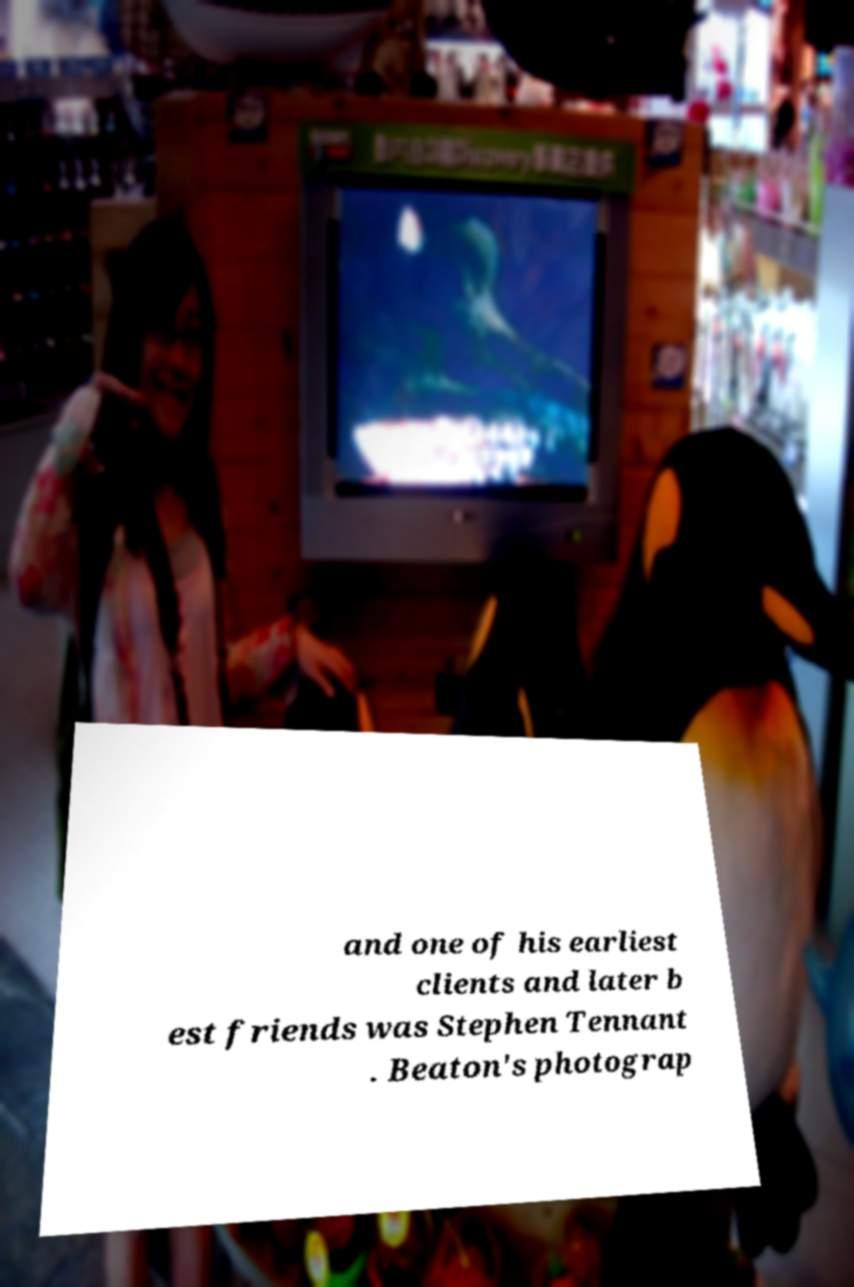Could you extract and type out the text from this image? and one of his earliest clients and later b est friends was Stephen Tennant . Beaton's photograp 